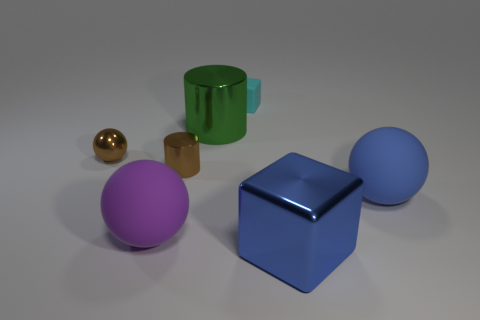Does the cyan matte thing behind the small brown cylinder have the same size as the matte thing that is left of the tiny cyan cube?
Provide a short and direct response. No. What number of rubber objects are in front of the small cyan rubber object and behind the big blue matte ball?
Your answer should be compact. 0. What color is the small shiny thing that is the same shape as the big purple rubber thing?
Offer a terse response. Brown. Are there fewer big brown objects than small shiny cylinders?
Offer a terse response. Yes. There is a blue metal thing; is its size the same as the block behind the big purple sphere?
Your response must be concise. No. There is a big thing in front of the matte sphere that is left of the green cylinder; what color is it?
Your answer should be compact. Blue. How many objects are matte balls that are on the right side of the tiny brown metal cylinder or things in front of the large blue sphere?
Provide a succinct answer. 3. Do the cyan cube and the green object have the same size?
Ensure brevity in your answer.  No. Are there any other things that are the same size as the matte cube?
Provide a succinct answer. Yes. There is a tiny brown metallic object that is right of the large purple matte object; is it the same shape as the blue matte object that is in front of the green object?
Provide a short and direct response. No. 